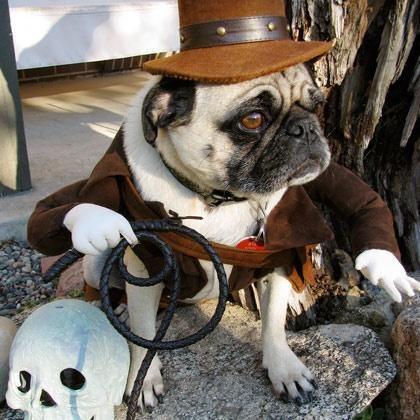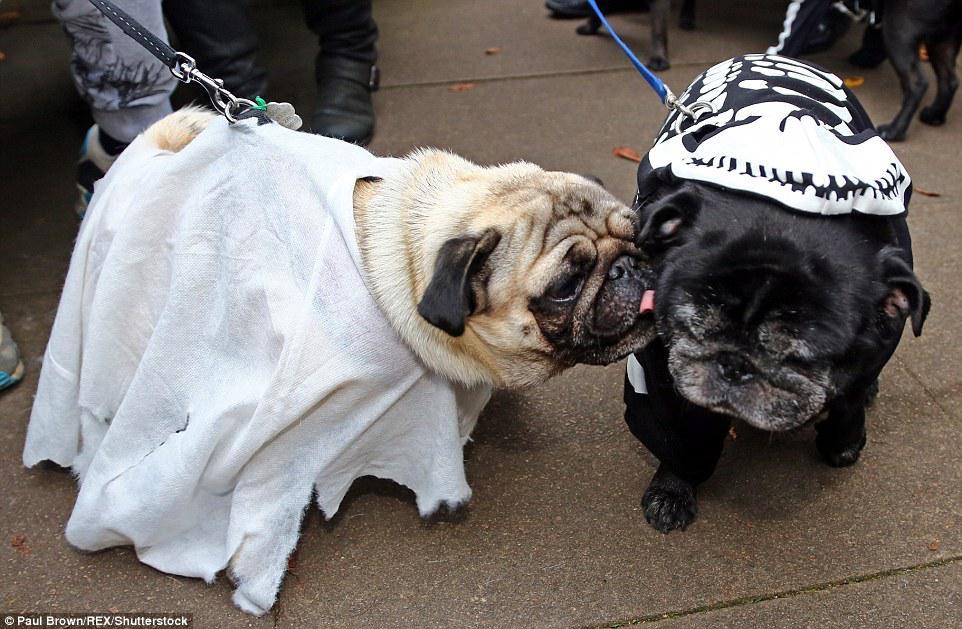The first image is the image on the left, the second image is the image on the right. Evaluate the accuracy of this statement regarding the images: "One image shows a beige pug in a white 'sheet' leaning its face into a black pug wearing a skeleton costume.". Is it true? Answer yes or no. Yes. The first image is the image on the left, the second image is the image on the right. Evaluate the accuracy of this statement regarding the images: "There is one dog touching another dog with their face in one of the images.". Is it true? Answer yes or no. Yes. 